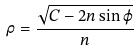Convert formula to latex. <formula><loc_0><loc_0><loc_500><loc_500>\rho = \frac { \sqrt { C - 2 n \sin \varphi } } { n }</formula> 